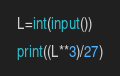Convert code to text. <code><loc_0><loc_0><loc_500><loc_500><_Python_>L=int(input())

print((L**3)/27)</code> 